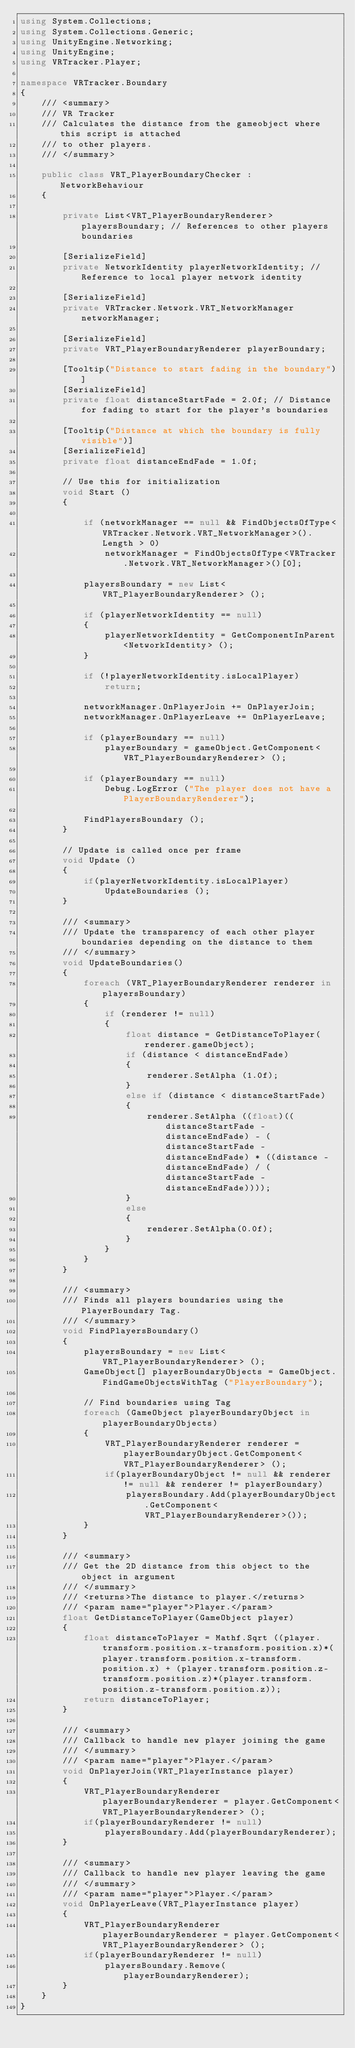<code> <loc_0><loc_0><loc_500><loc_500><_C#_>using System.Collections;
using System.Collections.Generic;
using UnityEngine.Networking;
using UnityEngine;
using VRTracker.Player;

namespace VRTracker.Boundary
{
    /// <summary>
    /// VR Tracker
    /// Calculates the distance from the gameobject where this script is attached
    /// to other players.
    /// </summary>

	public class VRT_PlayerBoundaryChecker : NetworkBehaviour 
	{

		private List<VRT_PlayerBoundaryRenderer> playersBoundary; // References to other players boundaries

		[SerializeField]
		private NetworkIdentity playerNetworkIdentity; // Reference to local player network identity

		[SerializeField]
		private VRTracker.Network.VRT_NetworkManager networkManager;

		[SerializeField]
		private VRT_PlayerBoundaryRenderer playerBoundary;

		[Tooltip("Distance to start fading in the boundary")]
		[SerializeField]
		private float distanceStartFade = 2.0f; // Distance for fading to start for the player's boundaries

		[Tooltip("Distance at which the boundary is fully visible")]
		[SerializeField]
		private float distanceEndFade = 1.0f;

		// Use this for initialization
		void Start () 
		{

            if (networkManager == null && FindObjectsOfType<VRTracker.Network.VRT_NetworkManager>().Length > 0)
                networkManager = FindObjectsOfType<VRTracker.Network.VRT_NetworkManager>()[0];

			playersBoundary = new List<VRT_PlayerBoundaryRenderer> ();

			if (playerNetworkIdentity == null) 
			{
				playerNetworkIdentity = GetComponentInParent<NetworkIdentity> ();
			}

			if (!playerNetworkIdentity.isLocalPlayer)
				return;
			
			networkManager.OnPlayerJoin += OnPlayerJoin;
			networkManager.OnPlayerLeave += OnPlayerLeave;

			if (playerBoundary == null)
				playerBoundary = gameObject.GetComponent<VRT_PlayerBoundaryRenderer> ();
			
			if (playerBoundary == null)
				Debug.LogError ("The player does not have a PlayerBoundaryRenderer");

			FindPlayersBoundary ();
		}
		
		// Update is called once per frame
		void Update () 
		{
			if(playerNetworkIdentity.isLocalPlayer)
				UpdateBoundaries ();
		}

        /// <summary>
        /// Update the transparency of each other player boundaries depending on the distance to them
        /// </summary>
		void UpdateBoundaries()
		{
            foreach (VRT_PlayerBoundaryRenderer renderer in playersBoundary)
            {
                if (renderer != null)
                {
                    float distance = GetDistanceToPlayer(renderer.gameObject);
					if (distance < distanceEndFade)
					{
						renderer.SetAlpha (1.0f);
					} 
					else if (distance < distanceStartFade) 
					{
						renderer.SetAlpha ((float)((distanceStartFade - distanceEndFade) - (distanceStartFade - distanceEndFade) * ((distance - distanceEndFade) / (distanceStartFade - distanceEndFade))));
					} 
					else 
					{
						renderer.SetAlpha(0.0f);
					}
                }
            }
		}

        /// <summary>
        /// Finds all players boundaries using the PlayerBoundary Tag.
        /// </summary>
		void FindPlayersBoundary()
		{
			playersBoundary = new List<VRT_PlayerBoundaryRenderer> ();
			GameObject[] playerBoundaryObjects = GameObject.FindGameObjectsWithTag ("PlayerBoundary");
            
            // Find boundaries using Tag
			foreach (GameObject playerBoundaryObject in playerBoundaryObjects) 
			{
                VRT_PlayerBoundaryRenderer renderer = playerBoundaryObject.GetComponent<VRT_PlayerBoundaryRenderer> ();
                if(playerBoundaryObject != null && renderer != null && renderer != playerBoundary)
                    playersBoundary.Add(playerBoundaryObject.GetComponent<VRT_PlayerBoundaryRenderer>());
			}
		}

        /// <summary>
        /// Get the 2D distance from this object to the object in argument
        /// </summary>
        /// <returns>The distance to player.</returns>
        /// <param name="player">Player.</param>
		float GetDistanceToPlayer(GameObject player)
		{
			float distanceToPlayer = Mathf.Sqrt ((player.transform.position.x-transform.position.x)*(player.transform.position.x-transform.position.x) + (player.transform.position.z-transform.position.z)*(player.transform.position.z-transform.position.z));
			return distanceToPlayer;
		}

        /// <summary>
        /// Callback to handle new player joining the game
        /// </summary>
        /// <param name="player">Player.</param>
		void OnPlayerJoin(VRT_PlayerInstance player)
		{
			VRT_PlayerBoundaryRenderer playerBoundaryRenderer = player.GetComponent<VRT_PlayerBoundaryRenderer> ();
			if(playerBoundaryRenderer != null)
				playersBoundary.Add(playerBoundaryRenderer);
		}

        /// <summary>
        /// Callback to handle new player leaving the game
        /// </summary>
        /// <param name="player">Player.</param>
		void OnPlayerLeave(VRT_PlayerInstance player)
		{
			VRT_PlayerBoundaryRenderer playerBoundaryRenderer = player.GetComponent<VRT_PlayerBoundaryRenderer> ();
			if(playerBoundaryRenderer != null)
				playersBoundary.Remove(playerBoundaryRenderer);
		}
	}
}
</code> 